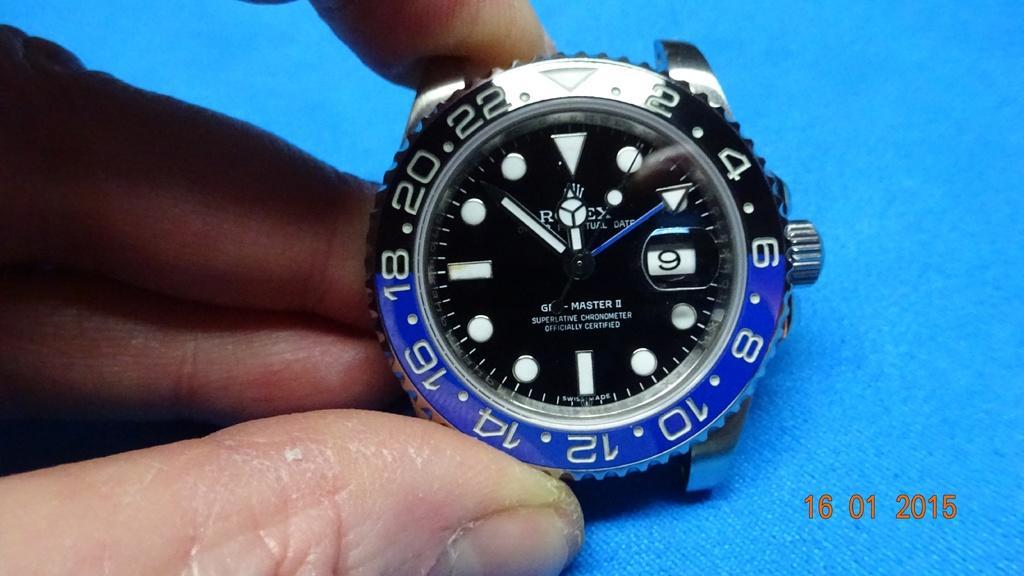Describe this image in one or two sentences. As we can see in the image there is a human hand holding a watch. 